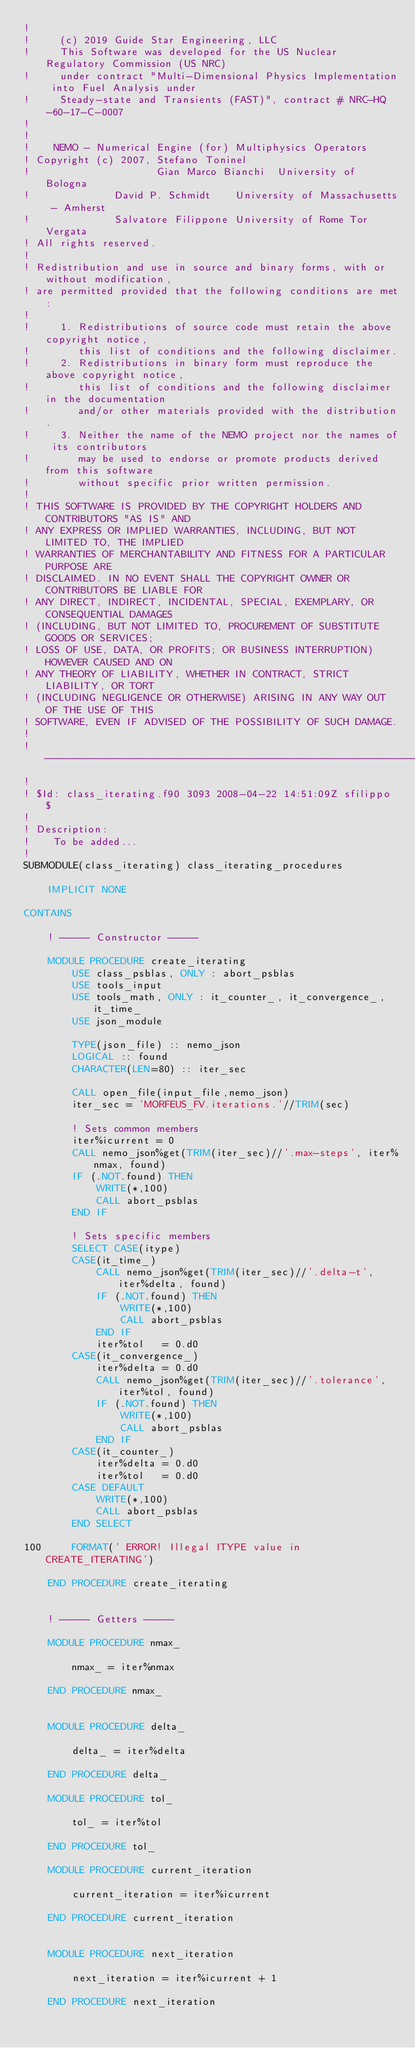Convert code to text. <code><loc_0><loc_0><loc_500><loc_500><_FORTRAN_>!
!     (c) 2019 Guide Star Engineering, LLC
!     This Software was developed for the US Nuclear Regulatory Commission (US NRC)
!     under contract "Multi-Dimensional Physics Implementation into Fuel Analysis under
!     Steady-state and Transients (FAST)", contract # NRC-HQ-60-17-C-0007
!
!
!    NEMO - Numerical Engine (for) Multiphysics Operators
! Copyright (c) 2007, Stefano Toninel
!                     Gian Marco Bianchi  University of Bologna
!              David P. Schmidt    University of Massachusetts - Amherst
!              Salvatore Filippone University of Rome Tor Vergata
! All rights reserved.
!
! Redistribution and use in source and binary forms, with or without modification,
! are permitted provided that the following conditions are met:
!
!     1. Redistributions of source code must retain the above copyright notice,
!        this list of conditions and the following disclaimer.
!     2. Redistributions in binary form must reproduce the above copyright notice,
!        this list of conditions and the following disclaimer in the documentation
!        and/or other materials provided with the distribution.
!     3. Neither the name of the NEMO project nor the names of its contributors
!        may be used to endorse or promote products derived from this software
!        without specific prior written permission.
!
! THIS SOFTWARE IS PROVIDED BY THE COPYRIGHT HOLDERS AND CONTRIBUTORS "AS IS" AND
! ANY EXPRESS OR IMPLIED WARRANTIES, INCLUDING, BUT NOT LIMITED TO, THE IMPLIED
! WARRANTIES OF MERCHANTABILITY AND FITNESS FOR A PARTICULAR PURPOSE ARE
! DISCLAIMED. IN NO EVENT SHALL THE COPYRIGHT OWNER OR CONTRIBUTORS BE LIABLE FOR
! ANY DIRECT, INDIRECT, INCIDENTAL, SPECIAL, EXEMPLARY, OR CONSEQUENTIAL DAMAGES
! (INCLUDING, BUT NOT LIMITED TO, PROCUREMENT OF SUBSTITUTE GOODS OR SERVICES;
! LOSS OF USE, DATA, OR PROFITS; OR BUSINESS INTERRUPTION) HOWEVER CAUSED AND ON
! ANY THEORY OF LIABILITY, WHETHER IN CONTRACT, STRICT LIABILITY, OR TORT
! (INCLUDING NEGLIGENCE OR OTHERWISE) ARISING IN ANY WAY OUT OF THE USE OF THIS
! SOFTWARE, EVEN IF ADVISED OF THE POSSIBILITY OF SUCH DAMAGE.
!
!---------------------------------------------------------------------------------
!
! $Id: class_iterating.f90 3093 2008-04-22 14:51:09Z sfilippo $
!
! Description:
!    To be added...
!
SUBMODULE(class_iterating) class_iterating_procedures

    IMPLICIT NONE

CONTAINS

    ! ----- Constructor -----

    MODULE PROCEDURE create_iterating
        USE class_psblas, ONLY : abort_psblas
        USE tools_input
        USE tools_math, ONLY : it_counter_, it_convergence_, it_time_
        USE json_module

        TYPE(json_file) :: nemo_json
        LOGICAL :: found
        CHARACTER(LEN=80) :: iter_sec

        CALL open_file(input_file,nemo_json)
        iter_sec = 'MORFEUS_FV.iterations.'//TRIM(sec)

        ! Sets common members
        iter%icurrent = 0
        CALL nemo_json%get(TRIM(iter_sec)//'.max-steps', iter%nmax, found)
        IF (.NOT.found) THEN
            WRITE(*,100)
            CALL abort_psblas
        END IF

        ! Sets specific members
        SELECT CASE(itype)
        CASE(it_time_)
            CALL nemo_json%get(TRIM(iter_sec)//'.delta-t', iter%delta, found)
            IF (.NOT.found) THEN
                WRITE(*,100)
                CALL abort_psblas
            END IF
            iter%tol   = 0.d0
        CASE(it_convergence_)
            iter%delta = 0.d0
            CALL nemo_json%get(TRIM(iter_sec)//'.tolerance', iter%tol, found)
            IF (.NOT.found) THEN
                WRITE(*,100)
                CALL abort_psblas
            END IF
        CASE(it_counter_)
            iter%delta = 0.d0
            iter%tol   = 0.d0
        CASE DEFAULT
            WRITE(*,100)
            CALL abort_psblas
        END SELECT

100     FORMAT(' ERROR! Illegal ITYPE value in CREATE_ITERATING')

    END PROCEDURE create_iterating


    ! ----- Getters -----

    MODULE PROCEDURE nmax_

        nmax_ = iter%nmax

    END PROCEDURE nmax_


    MODULE PROCEDURE delta_

        delta_ = iter%delta

    END PROCEDURE delta_

    MODULE PROCEDURE tol_

        tol_ = iter%tol

    END PROCEDURE tol_

    MODULE PROCEDURE current_iteration

        current_iteration = iter%icurrent

    END PROCEDURE current_iteration


    MODULE PROCEDURE next_iteration

        next_iteration = iter%icurrent + 1

    END PROCEDURE next_iteration

</code> 